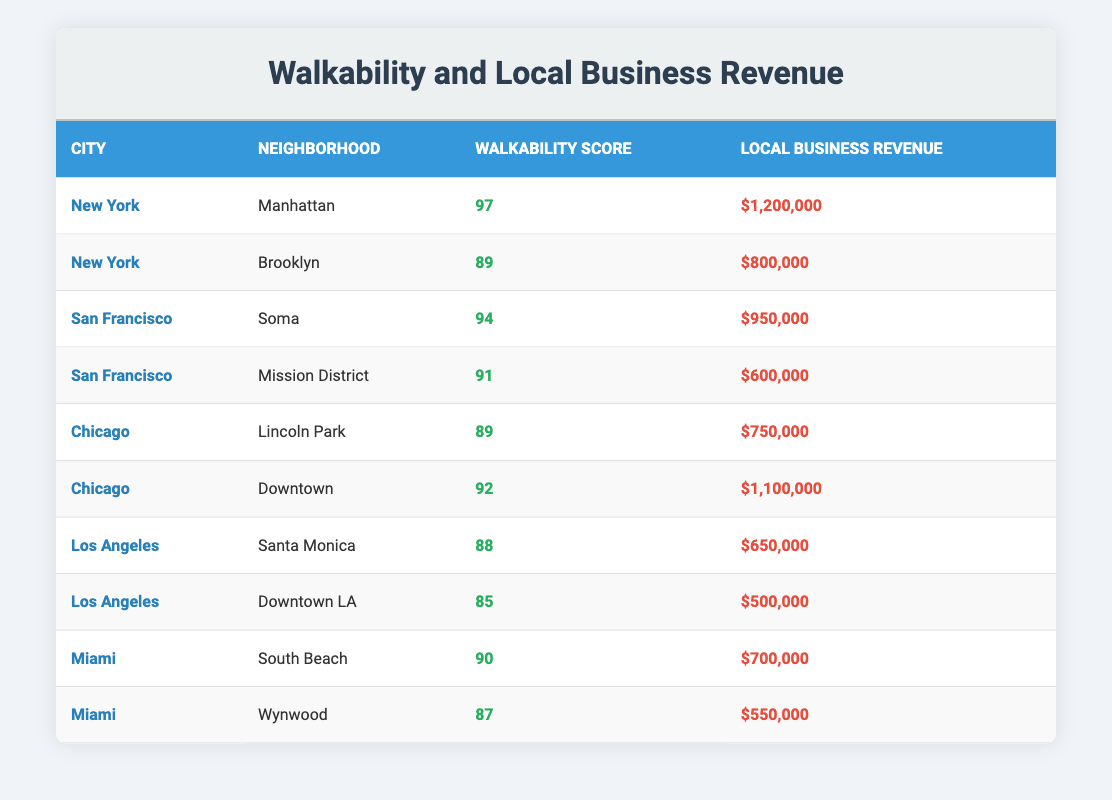What is the Walkability Score of the Manhattan neighborhood? The table clearly shows that the Manhattan neighborhood has a Walkability Score of 97.
Answer: 97 What is the total Local Business Revenue of neighborhoods in New York? The Local Business Revenues for New York neighborhoods are $1,200,000 (Manhattan) and $800,000 (Brooklyn). Adding these gives $1,200,000 + $800,000 = $2,000,000.
Answer: $2,000,000 Is the Walkability Score of Soma greater than that of Downtown LA? The table shows that the Walkability Score of Soma is 94 and for Downtown LA, it is 85. Since 94 is greater than 85, the answer is yes.
Answer: Yes What is the average Walkability Score for neighborhoods in San Francisco? The Walkability Scores for San Francisco are 94 (Soma) and 91 (Mission District). To find the average, add them: 94 + 91 = 185, and then divide by 2, which gives 185/2 = 92.5.
Answer: 92.5 Do neighborhoods with a Walkability Score above 90 all have Local Business Revenues exceeding $700,000? The neighborhoods with a Walkability Score above 90 are Manhattan (97, $1,200,000), Soma (94, $950,000), Downtown (92, $1,100,000), and South Beach (90, $700,000). South Beach has exactly $700,000, which does not exceed it, therefore, the answer is no.
Answer: No What is the difference between the highest and lowest Local Business Revenue in the dataset? The highest Local Business Revenue is $1,200,000 (Manhattan), and the lowest is $500,000 (Downtown LA). The difference is $1,200,000 - $500,000 = $700,000.
Answer: $700,000 Which city has the neighborhood with the lowest Local Business Revenue, and what is the amount? The neighborhood with the lowest Local Business Revenue is Downtown LA, which is in Los Angeles, and the amount is $500,000.
Answer: Los Angeles, $500,000 What is the maximum Walkability Score in the table? The maximum Walkability Score can be identified by looking through the Walkability Scores, with Manhattan showing the highest at 97.
Answer: 97 How many neighborhoods have a Walkability Score lower than 90? The neighborhoods with Walkability Scores lower than 90 are Santa Monica (88), Downtown LA (85), and Wynwood (87). That gives a total of 3 neighborhoods.
Answer: 3 